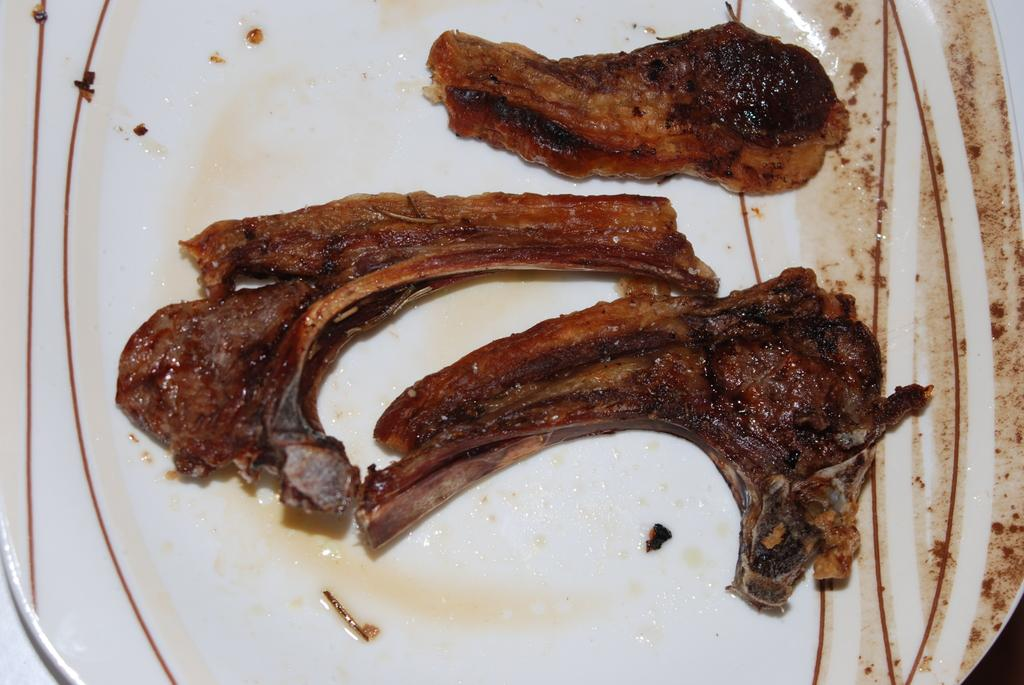What types of items can be seen in the image? There are food items in the image. What is the color of the plate on which the food items are placed? The plate is white in color. Can you hear the band playing in the background of the image? There is no band or any sound mentioned in the image, so it cannot be heard. 